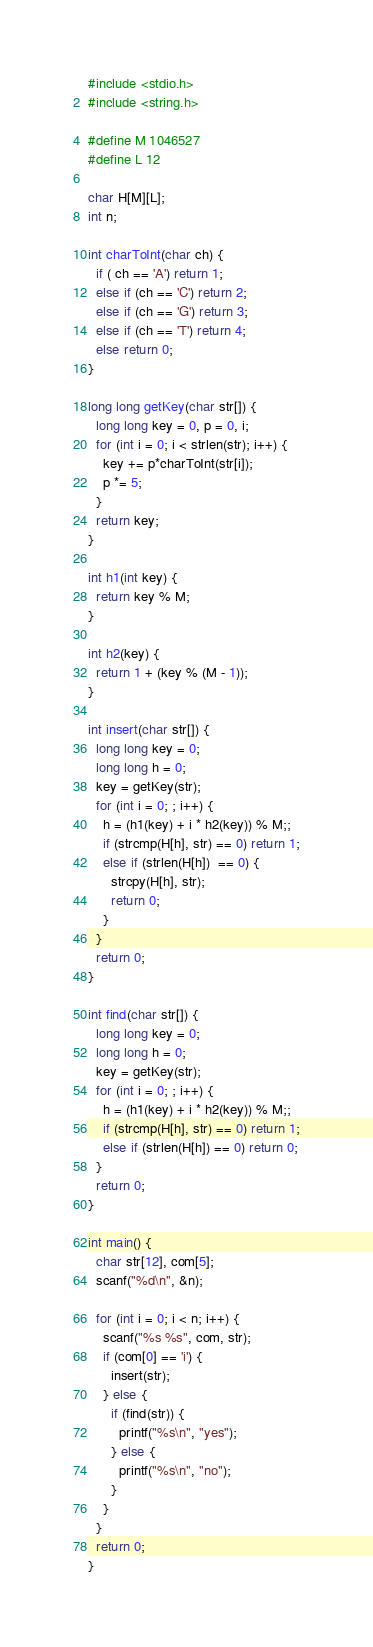Convert code to text. <code><loc_0><loc_0><loc_500><loc_500><_C_>#include <stdio.h>
#include <string.h>

#define M 1046527
#define L 12

char H[M][L];
int n;

int charToInt(char ch) {
  if ( ch == 'A') return 1;
  else if (ch == 'C') return 2;
  else if (ch == 'G') return 3;
  else if (ch == 'T') return 4;
  else return 0;
}

long long getKey(char str[]) {
  long long key = 0, p = 0, i;
  for (int i = 0; i < strlen(str); i++) {
    key += p*charToInt(str[i]);
    p *= 5;
  }
  return key;
}

int h1(int key) {
  return key % M;
}

int h2(key) {
  return 1 + (key % (M - 1));
}

int insert(char str[]) {
  long long key = 0;
  long long h = 0;
  key = getKey(str);
  for (int i = 0; ; i++) {
    h = (h1(key) + i * h2(key)) % M;;
    if (strcmp(H[h], str) == 0) return 1;
    else if (strlen(H[h])  == 0) {
      strcpy(H[h], str);
      return 0;
    }
  }
  return 0;
}

int find(char str[]) {
  long long key = 0;
  long long h = 0;
  key = getKey(str);
  for (int i = 0; ; i++) {
    h = (h1(key) + i * h2(key)) % M;;
    if (strcmp(H[h], str) == 0) return 1;
    else if (strlen(H[h]) == 0) return 0;
  }
  return 0;
}

int main() {
  char str[12], com[5];
  scanf("%d\n", &n);

  for (int i = 0; i < n; i++) {
    scanf("%s %s", com, str);
    if (com[0] == 'i') {
      insert(str);
    } else {
      if (find(str)) {
        printf("%s\n", "yes");
      } else {
        printf("%s\n", "no");
      }
    }
  }
  return 0;
}

</code> 